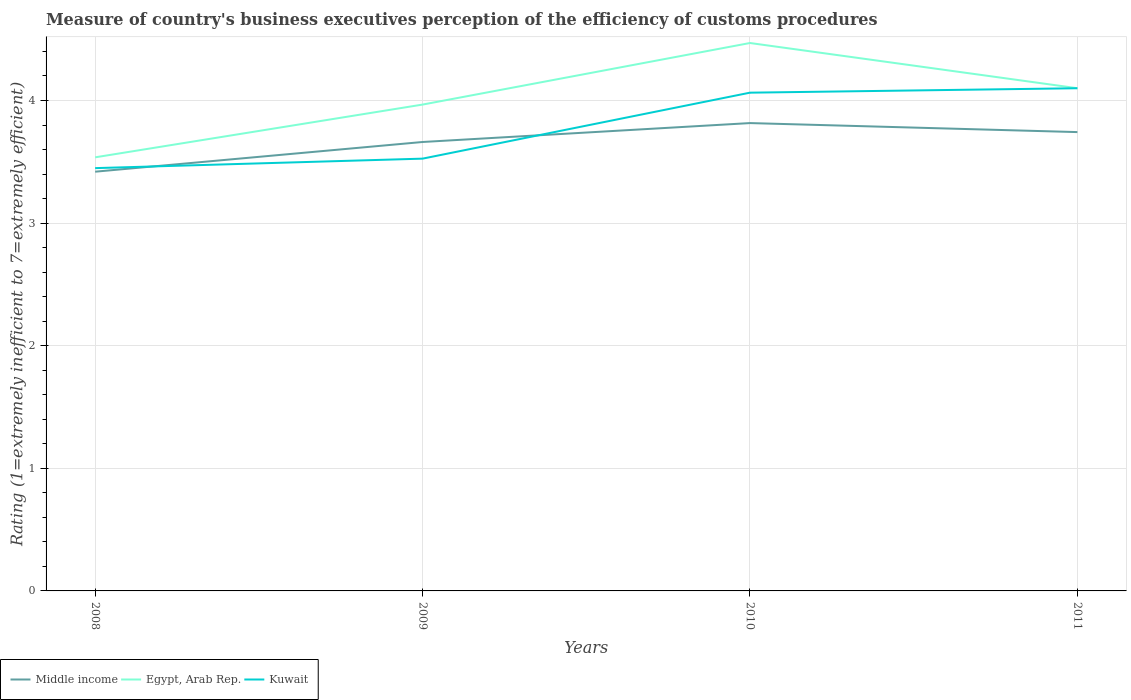How many different coloured lines are there?
Your answer should be very brief. 3. Is the number of lines equal to the number of legend labels?
Keep it short and to the point. Yes. Across all years, what is the maximum rating of the efficiency of customs procedure in Middle income?
Make the answer very short. 3.42. In which year was the rating of the efficiency of customs procedure in Egypt, Arab Rep. maximum?
Provide a succinct answer. 2008. What is the total rating of the efficiency of customs procedure in Egypt, Arab Rep. in the graph?
Give a very brief answer. 0.37. What is the difference between the highest and the second highest rating of the efficiency of customs procedure in Egypt, Arab Rep.?
Provide a short and direct response. 0.93. What is the difference between two consecutive major ticks on the Y-axis?
Your response must be concise. 1. Are the values on the major ticks of Y-axis written in scientific E-notation?
Offer a terse response. No. Does the graph contain any zero values?
Provide a short and direct response. No. Where does the legend appear in the graph?
Provide a succinct answer. Bottom left. How many legend labels are there?
Keep it short and to the point. 3. What is the title of the graph?
Keep it short and to the point. Measure of country's business executives perception of the efficiency of customs procedures. Does "Zambia" appear as one of the legend labels in the graph?
Keep it short and to the point. No. What is the label or title of the X-axis?
Your answer should be very brief. Years. What is the label or title of the Y-axis?
Ensure brevity in your answer.  Rating (1=extremely inefficient to 7=extremely efficient). What is the Rating (1=extremely inefficient to 7=extremely efficient) of Middle income in 2008?
Offer a terse response. 3.42. What is the Rating (1=extremely inefficient to 7=extremely efficient) in Egypt, Arab Rep. in 2008?
Offer a very short reply. 3.54. What is the Rating (1=extremely inefficient to 7=extremely efficient) of Kuwait in 2008?
Your response must be concise. 3.45. What is the Rating (1=extremely inefficient to 7=extremely efficient) of Middle income in 2009?
Give a very brief answer. 3.66. What is the Rating (1=extremely inefficient to 7=extremely efficient) of Egypt, Arab Rep. in 2009?
Provide a succinct answer. 3.97. What is the Rating (1=extremely inefficient to 7=extremely efficient) of Kuwait in 2009?
Your response must be concise. 3.53. What is the Rating (1=extremely inefficient to 7=extremely efficient) of Middle income in 2010?
Your response must be concise. 3.82. What is the Rating (1=extremely inefficient to 7=extremely efficient) in Egypt, Arab Rep. in 2010?
Provide a succinct answer. 4.47. What is the Rating (1=extremely inefficient to 7=extremely efficient) of Kuwait in 2010?
Provide a succinct answer. 4.06. What is the Rating (1=extremely inefficient to 7=extremely efficient) of Middle income in 2011?
Your answer should be compact. 3.74. What is the Rating (1=extremely inefficient to 7=extremely efficient) of Kuwait in 2011?
Ensure brevity in your answer.  4.1. Across all years, what is the maximum Rating (1=extremely inefficient to 7=extremely efficient) of Middle income?
Your response must be concise. 3.82. Across all years, what is the maximum Rating (1=extremely inefficient to 7=extremely efficient) of Egypt, Arab Rep.?
Provide a succinct answer. 4.47. Across all years, what is the minimum Rating (1=extremely inefficient to 7=extremely efficient) in Middle income?
Give a very brief answer. 3.42. Across all years, what is the minimum Rating (1=extremely inefficient to 7=extremely efficient) in Egypt, Arab Rep.?
Provide a short and direct response. 3.54. Across all years, what is the minimum Rating (1=extremely inefficient to 7=extremely efficient) in Kuwait?
Make the answer very short. 3.45. What is the total Rating (1=extremely inefficient to 7=extremely efficient) of Middle income in the graph?
Provide a succinct answer. 14.64. What is the total Rating (1=extremely inefficient to 7=extremely efficient) of Egypt, Arab Rep. in the graph?
Offer a terse response. 16.07. What is the total Rating (1=extremely inefficient to 7=extremely efficient) of Kuwait in the graph?
Offer a terse response. 15.14. What is the difference between the Rating (1=extremely inefficient to 7=extremely efficient) of Middle income in 2008 and that in 2009?
Offer a very short reply. -0.24. What is the difference between the Rating (1=extremely inefficient to 7=extremely efficient) in Egypt, Arab Rep. in 2008 and that in 2009?
Your answer should be very brief. -0.43. What is the difference between the Rating (1=extremely inefficient to 7=extremely efficient) of Kuwait in 2008 and that in 2009?
Your answer should be compact. -0.08. What is the difference between the Rating (1=extremely inefficient to 7=extremely efficient) in Middle income in 2008 and that in 2010?
Offer a terse response. -0.4. What is the difference between the Rating (1=extremely inefficient to 7=extremely efficient) of Egypt, Arab Rep. in 2008 and that in 2010?
Keep it short and to the point. -0.93. What is the difference between the Rating (1=extremely inefficient to 7=extremely efficient) of Kuwait in 2008 and that in 2010?
Offer a very short reply. -0.62. What is the difference between the Rating (1=extremely inefficient to 7=extremely efficient) in Middle income in 2008 and that in 2011?
Ensure brevity in your answer.  -0.32. What is the difference between the Rating (1=extremely inefficient to 7=extremely efficient) in Egypt, Arab Rep. in 2008 and that in 2011?
Your answer should be compact. -0.56. What is the difference between the Rating (1=extremely inefficient to 7=extremely efficient) of Kuwait in 2008 and that in 2011?
Provide a succinct answer. -0.65. What is the difference between the Rating (1=extremely inefficient to 7=extremely efficient) in Middle income in 2009 and that in 2010?
Ensure brevity in your answer.  -0.15. What is the difference between the Rating (1=extremely inefficient to 7=extremely efficient) of Egypt, Arab Rep. in 2009 and that in 2010?
Ensure brevity in your answer.  -0.5. What is the difference between the Rating (1=extremely inefficient to 7=extremely efficient) in Kuwait in 2009 and that in 2010?
Make the answer very short. -0.54. What is the difference between the Rating (1=extremely inefficient to 7=extremely efficient) in Middle income in 2009 and that in 2011?
Offer a terse response. -0.08. What is the difference between the Rating (1=extremely inefficient to 7=extremely efficient) in Egypt, Arab Rep. in 2009 and that in 2011?
Provide a succinct answer. -0.13. What is the difference between the Rating (1=extremely inefficient to 7=extremely efficient) of Kuwait in 2009 and that in 2011?
Ensure brevity in your answer.  -0.57. What is the difference between the Rating (1=extremely inefficient to 7=extremely efficient) of Middle income in 2010 and that in 2011?
Provide a short and direct response. 0.07. What is the difference between the Rating (1=extremely inefficient to 7=extremely efficient) of Egypt, Arab Rep. in 2010 and that in 2011?
Your response must be concise. 0.37. What is the difference between the Rating (1=extremely inefficient to 7=extremely efficient) in Kuwait in 2010 and that in 2011?
Ensure brevity in your answer.  -0.04. What is the difference between the Rating (1=extremely inefficient to 7=extremely efficient) of Middle income in 2008 and the Rating (1=extremely inefficient to 7=extremely efficient) of Egypt, Arab Rep. in 2009?
Offer a terse response. -0.55. What is the difference between the Rating (1=extremely inefficient to 7=extremely efficient) in Middle income in 2008 and the Rating (1=extremely inefficient to 7=extremely efficient) in Kuwait in 2009?
Offer a terse response. -0.11. What is the difference between the Rating (1=extremely inefficient to 7=extremely efficient) in Egypt, Arab Rep. in 2008 and the Rating (1=extremely inefficient to 7=extremely efficient) in Kuwait in 2009?
Make the answer very short. 0.01. What is the difference between the Rating (1=extremely inefficient to 7=extremely efficient) in Middle income in 2008 and the Rating (1=extremely inefficient to 7=extremely efficient) in Egypt, Arab Rep. in 2010?
Your answer should be compact. -1.05. What is the difference between the Rating (1=extremely inefficient to 7=extremely efficient) of Middle income in 2008 and the Rating (1=extremely inefficient to 7=extremely efficient) of Kuwait in 2010?
Ensure brevity in your answer.  -0.64. What is the difference between the Rating (1=extremely inefficient to 7=extremely efficient) in Egypt, Arab Rep. in 2008 and the Rating (1=extremely inefficient to 7=extremely efficient) in Kuwait in 2010?
Offer a terse response. -0.53. What is the difference between the Rating (1=extremely inefficient to 7=extremely efficient) in Middle income in 2008 and the Rating (1=extremely inefficient to 7=extremely efficient) in Egypt, Arab Rep. in 2011?
Provide a succinct answer. -0.68. What is the difference between the Rating (1=extremely inefficient to 7=extremely efficient) in Middle income in 2008 and the Rating (1=extremely inefficient to 7=extremely efficient) in Kuwait in 2011?
Your answer should be compact. -0.68. What is the difference between the Rating (1=extremely inefficient to 7=extremely efficient) of Egypt, Arab Rep. in 2008 and the Rating (1=extremely inefficient to 7=extremely efficient) of Kuwait in 2011?
Offer a terse response. -0.56. What is the difference between the Rating (1=extremely inefficient to 7=extremely efficient) in Middle income in 2009 and the Rating (1=extremely inefficient to 7=extremely efficient) in Egypt, Arab Rep. in 2010?
Give a very brief answer. -0.81. What is the difference between the Rating (1=extremely inefficient to 7=extremely efficient) of Middle income in 2009 and the Rating (1=extremely inefficient to 7=extremely efficient) of Kuwait in 2010?
Ensure brevity in your answer.  -0.4. What is the difference between the Rating (1=extremely inefficient to 7=extremely efficient) in Egypt, Arab Rep. in 2009 and the Rating (1=extremely inefficient to 7=extremely efficient) in Kuwait in 2010?
Provide a short and direct response. -0.1. What is the difference between the Rating (1=extremely inefficient to 7=extremely efficient) in Middle income in 2009 and the Rating (1=extremely inefficient to 7=extremely efficient) in Egypt, Arab Rep. in 2011?
Offer a terse response. -0.44. What is the difference between the Rating (1=extremely inefficient to 7=extremely efficient) of Middle income in 2009 and the Rating (1=extremely inefficient to 7=extremely efficient) of Kuwait in 2011?
Provide a short and direct response. -0.44. What is the difference between the Rating (1=extremely inefficient to 7=extremely efficient) of Egypt, Arab Rep. in 2009 and the Rating (1=extremely inefficient to 7=extremely efficient) of Kuwait in 2011?
Keep it short and to the point. -0.13. What is the difference between the Rating (1=extremely inefficient to 7=extremely efficient) in Middle income in 2010 and the Rating (1=extremely inefficient to 7=extremely efficient) in Egypt, Arab Rep. in 2011?
Give a very brief answer. -0.28. What is the difference between the Rating (1=extremely inefficient to 7=extremely efficient) of Middle income in 2010 and the Rating (1=extremely inefficient to 7=extremely efficient) of Kuwait in 2011?
Offer a terse response. -0.28. What is the difference between the Rating (1=extremely inefficient to 7=extremely efficient) of Egypt, Arab Rep. in 2010 and the Rating (1=extremely inefficient to 7=extremely efficient) of Kuwait in 2011?
Provide a succinct answer. 0.37. What is the average Rating (1=extremely inefficient to 7=extremely efficient) of Middle income per year?
Provide a short and direct response. 3.66. What is the average Rating (1=extremely inefficient to 7=extremely efficient) of Egypt, Arab Rep. per year?
Provide a short and direct response. 4.02. What is the average Rating (1=extremely inefficient to 7=extremely efficient) of Kuwait per year?
Offer a very short reply. 3.78. In the year 2008, what is the difference between the Rating (1=extremely inefficient to 7=extremely efficient) of Middle income and Rating (1=extremely inefficient to 7=extremely efficient) of Egypt, Arab Rep.?
Provide a short and direct response. -0.12. In the year 2008, what is the difference between the Rating (1=extremely inefficient to 7=extremely efficient) of Middle income and Rating (1=extremely inefficient to 7=extremely efficient) of Kuwait?
Provide a succinct answer. -0.03. In the year 2008, what is the difference between the Rating (1=extremely inefficient to 7=extremely efficient) in Egypt, Arab Rep. and Rating (1=extremely inefficient to 7=extremely efficient) in Kuwait?
Give a very brief answer. 0.09. In the year 2009, what is the difference between the Rating (1=extremely inefficient to 7=extremely efficient) in Middle income and Rating (1=extremely inefficient to 7=extremely efficient) in Egypt, Arab Rep.?
Your response must be concise. -0.31. In the year 2009, what is the difference between the Rating (1=extremely inefficient to 7=extremely efficient) in Middle income and Rating (1=extremely inefficient to 7=extremely efficient) in Kuwait?
Provide a succinct answer. 0.14. In the year 2009, what is the difference between the Rating (1=extremely inefficient to 7=extremely efficient) in Egypt, Arab Rep. and Rating (1=extremely inefficient to 7=extremely efficient) in Kuwait?
Keep it short and to the point. 0.44. In the year 2010, what is the difference between the Rating (1=extremely inefficient to 7=extremely efficient) of Middle income and Rating (1=extremely inefficient to 7=extremely efficient) of Egypt, Arab Rep.?
Offer a terse response. -0.65. In the year 2010, what is the difference between the Rating (1=extremely inefficient to 7=extremely efficient) of Middle income and Rating (1=extremely inefficient to 7=extremely efficient) of Kuwait?
Offer a terse response. -0.25. In the year 2010, what is the difference between the Rating (1=extremely inefficient to 7=extremely efficient) in Egypt, Arab Rep. and Rating (1=extremely inefficient to 7=extremely efficient) in Kuwait?
Your response must be concise. 0.41. In the year 2011, what is the difference between the Rating (1=extremely inefficient to 7=extremely efficient) of Middle income and Rating (1=extremely inefficient to 7=extremely efficient) of Egypt, Arab Rep.?
Ensure brevity in your answer.  -0.36. In the year 2011, what is the difference between the Rating (1=extremely inefficient to 7=extremely efficient) in Middle income and Rating (1=extremely inefficient to 7=extremely efficient) in Kuwait?
Give a very brief answer. -0.36. In the year 2011, what is the difference between the Rating (1=extremely inefficient to 7=extremely efficient) in Egypt, Arab Rep. and Rating (1=extremely inefficient to 7=extremely efficient) in Kuwait?
Provide a short and direct response. 0. What is the ratio of the Rating (1=extremely inefficient to 7=extremely efficient) in Middle income in 2008 to that in 2009?
Provide a short and direct response. 0.93. What is the ratio of the Rating (1=extremely inefficient to 7=extremely efficient) of Egypt, Arab Rep. in 2008 to that in 2009?
Provide a succinct answer. 0.89. What is the ratio of the Rating (1=extremely inefficient to 7=extremely efficient) in Kuwait in 2008 to that in 2009?
Your response must be concise. 0.98. What is the ratio of the Rating (1=extremely inefficient to 7=extremely efficient) in Middle income in 2008 to that in 2010?
Keep it short and to the point. 0.9. What is the ratio of the Rating (1=extremely inefficient to 7=extremely efficient) in Egypt, Arab Rep. in 2008 to that in 2010?
Provide a short and direct response. 0.79. What is the ratio of the Rating (1=extremely inefficient to 7=extremely efficient) in Kuwait in 2008 to that in 2010?
Make the answer very short. 0.85. What is the ratio of the Rating (1=extremely inefficient to 7=extremely efficient) in Middle income in 2008 to that in 2011?
Your answer should be compact. 0.91. What is the ratio of the Rating (1=extremely inefficient to 7=extremely efficient) in Egypt, Arab Rep. in 2008 to that in 2011?
Offer a very short reply. 0.86. What is the ratio of the Rating (1=extremely inefficient to 7=extremely efficient) of Kuwait in 2008 to that in 2011?
Offer a very short reply. 0.84. What is the ratio of the Rating (1=extremely inefficient to 7=extremely efficient) in Middle income in 2009 to that in 2010?
Your answer should be compact. 0.96. What is the ratio of the Rating (1=extremely inefficient to 7=extremely efficient) in Egypt, Arab Rep. in 2009 to that in 2010?
Offer a very short reply. 0.89. What is the ratio of the Rating (1=extremely inefficient to 7=extremely efficient) of Kuwait in 2009 to that in 2010?
Your response must be concise. 0.87. What is the ratio of the Rating (1=extremely inefficient to 7=extremely efficient) of Middle income in 2009 to that in 2011?
Ensure brevity in your answer.  0.98. What is the ratio of the Rating (1=extremely inefficient to 7=extremely efficient) of Egypt, Arab Rep. in 2009 to that in 2011?
Your response must be concise. 0.97. What is the ratio of the Rating (1=extremely inefficient to 7=extremely efficient) in Kuwait in 2009 to that in 2011?
Ensure brevity in your answer.  0.86. What is the ratio of the Rating (1=extremely inefficient to 7=extremely efficient) of Middle income in 2010 to that in 2011?
Provide a short and direct response. 1.02. What is the ratio of the Rating (1=extremely inefficient to 7=extremely efficient) in Egypt, Arab Rep. in 2010 to that in 2011?
Your answer should be compact. 1.09. What is the ratio of the Rating (1=extremely inefficient to 7=extremely efficient) of Kuwait in 2010 to that in 2011?
Offer a terse response. 0.99. What is the difference between the highest and the second highest Rating (1=extremely inefficient to 7=extremely efficient) in Middle income?
Provide a short and direct response. 0.07. What is the difference between the highest and the second highest Rating (1=extremely inefficient to 7=extremely efficient) in Egypt, Arab Rep.?
Provide a succinct answer. 0.37. What is the difference between the highest and the second highest Rating (1=extremely inefficient to 7=extremely efficient) of Kuwait?
Your answer should be compact. 0.04. What is the difference between the highest and the lowest Rating (1=extremely inefficient to 7=extremely efficient) in Middle income?
Your answer should be compact. 0.4. What is the difference between the highest and the lowest Rating (1=extremely inefficient to 7=extremely efficient) in Egypt, Arab Rep.?
Offer a terse response. 0.93. What is the difference between the highest and the lowest Rating (1=extremely inefficient to 7=extremely efficient) in Kuwait?
Offer a very short reply. 0.65. 